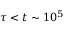<formula> <loc_0><loc_0><loc_500><loc_500>\tau < t \sim 1 0 ^ { 5 }</formula> 